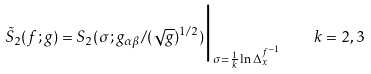Convert formula to latex. <formula><loc_0><loc_0><loc_500><loc_500>\tilde { S } _ { 2 } ( f ; g ) = { S } _ { 2 } ( \sigma ; g _ { \alpha \beta } / ( \sqrt { g } ) ^ { 1 / 2 } ) \Big | _ { \sigma = \frac { 1 } { k } \ln \Delta ^ { f ^ { - 1 } } _ { x } } \quad k = 2 , 3</formula> 